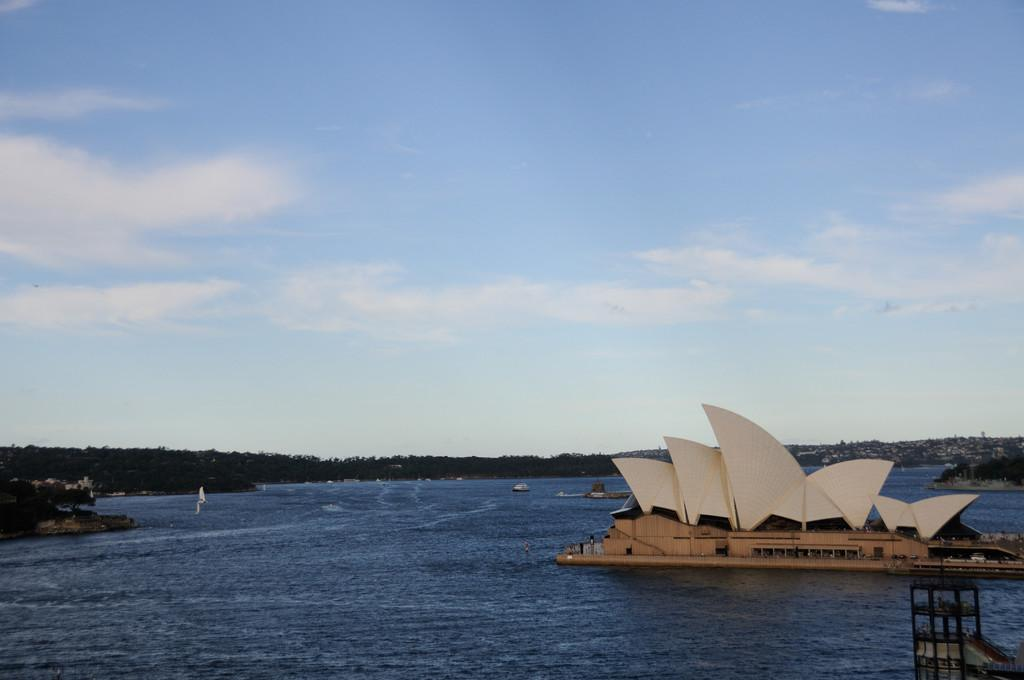What type of building is featured in the image? There is an opera house in the image. What natural feature can be seen in the image? There is a lake in the image. What type of vegetation is present in the image? There are trees in the image. How would you describe the sky in the image? The sky is visible in the image and appears cloudy. How many mice can be seen running around the opera house in the image? There are no mice present in the image; it features an opera house, a lake, trees, and a cloudy sky. 